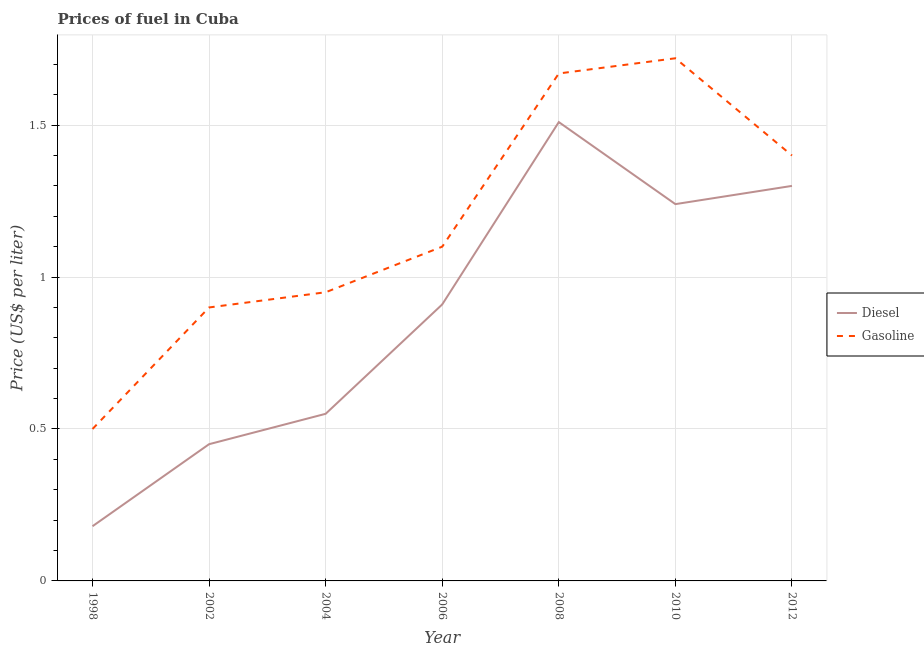Is the number of lines equal to the number of legend labels?
Give a very brief answer. Yes. What is the diesel price in 2004?
Provide a short and direct response. 0.55. Across all years, what is the maximum diesel price?
Make the answer very short. 1.51. Across all years, what is the minimum diesel price?
Offer a terse response. 0.18. In which year was the gasoline price maximum?
Make the answer very short. 2010. What is the total diesel price in the graph?
Provide a short and direct response. 6.14. What is the difference between the gasoline price in 2006 and that in 2010?
Make the answer very short. -0.62. What is the difference between the diesel price in 2012 and the gasoline price in 1998?
Offer a very short reply. 0.8. What is the average diesel price per year?
Your response must be concise. 0.88. In the year 2006, what is the difference between the diesel price and gasoline price?
Provide a short and direct response. -0.19. In how many years, is the gasoline price greater than 0.2 US$ per litre?
Make the answer very short. 7. What is the ratio of the diesel price in 2004 to that in 2008?
Provide a succinct answer. 0.36. What is the difference between the highest and the second highest gasoline price?
Your answer should be compact. 0.05. What is the difference between the highest and the lowest gasoline price?
Make the answer very short. 1.22. Does the gasoline price monotonically increase over the years?
Your answer should be very brief. No. How many lines are there?
Provide a succinct answer. 2. How many years are there in the graph?
Keep it short and to the point. 7. What is the difference between two consecutive major ticks on the Y-axis?
Make the answer very short. 0.5. Are the values on the major ticks of Y-axis written in scientific E-notation?
Give a very brief answer. No. What is the title of the graph?
Your answer should be compact. Prices of fuel in Cuba. Does "Exports" appear as one of the legend labels in the graph?
Your answer should be very brief. No. What is the label or title of the Y-axis?
Keep it short and to the point. Price (US$ per liter). What is the Price (US$ per liter) of Diesel in 1998?
Keep it short and to the point. 0.18. What is the Price (US$ per liter) in Diesel in 2002?
Your response must be concise. 0.45. What is the Price (US$ per liter) in Diesel in 2004?
Your answer should be very brief. 0.55. What is the Price (US$ per liter) of Diesel in 2006?
Give a very brief answer. 0.91. What is the Price (US$ per liter) in Diesel in 2008?
Give a very brief answer. 1.51. What is the Price (US$ per liter) in Gasoline in 2008?
Provide a short and direct response. 1.67. What is the Price (US$ per liter) of Diesel in 2010?
Offer a very short reply. 1.24. What is the Price (US$ per liter) in Gasoline in 2010?
Make the answer very short. 1.72. Across all years, what is the maximum Price (US$ per liter) in Diesel?
Ensure brevity in your answer.  1.51. Across all years, what is the maximum Price (US$ per liter) of Gasoline?
Offer a terse response. 1.72. Across all years, what is the minimum Price (US$ per liter) of Diesel?
Provide a short and direct response. 0.18. Across all years, what is the minimum Price (US$ per liter) in Gasoline?
Your answer should be compact. 0.5. What is the total Price (US$ per liter) in Diesel in the graph?
Give a very brief answer. 6.14. What is the total Price (US$ per liter) of Gasoline in the graph?
Keep it short and to the point. 8.24. What is the difference between the Price (US$ per liter) in Diesel in 1998 and that in 2002?
Your response must be concise. -0.27. What is the difference between the Price (US$ per liter) of Diesel in 1998 and that in 2004?
Offer a terse response. -0.37. What is the difference between the Price (US$ per liter) of Gasoline in 1998 and that in 2004?
Keep it short and to the point. -0.45. What is the difference between the Price (US$ per liter) of Diesel in 1998 and that in 2006?
Your answer should be very brief. -0.73. What is the difference between the Price (US$ per liter) of Gasoline in 1998 and that in 2006?
Provide a succinct answer. -0.6. What is the difference between the Price (US$ per liter) in Diesel in 1998 and that in 2008?
Your response must be concise. -1.33. What is the difference between the Price (US$ per liter) in Gasoline in 1998 and that in 2008?
Give a very brief answer. -1.17. What is the difference between the Price (US$ per liter) in Diesel in 1998 and that in 2010?
Provide a succinct answer. -1.06. What is the difference between the Price (US$ per liter) of Gasoline in 1998 and that in 2010?
Make the answer very short. -1.22. What is the difference between the Price (US$ per liter) of Diesel in 1998 and that in 2012?
Your answer should be compact. -1.12. What is the difference between the Price (US$ per liter) of Gasoline in 1998 and that in 2012?
Make the answer very short. -0.9. What is the difference between the Price (US$ per liter) in Gasoline in 2002 and that in 2004?
Give a very brief answer. -0.05. What is the difference between the Price (US$ per liter) of Diesel in 2002 and that in 2006?
Your response must be concise. -0.46. What is the difference between the Price (US$ per liter) in Gasoline in 2002 and that in 2006?
Provide a short and direct response. -0.2. What is the difference between the Price (US$ per liter) of Diesel in 2002 and that in 2008?
Provide a short and direct response. -1.06. What is the difference between the Price (US$ per liter) in Gasoline in 2002 and that in 2008?
Offer a very short reply. -0.77. What is the difference between the Price (US$ per liter) in Diesel in 2002 and that in 2010?
Ensure brevity in your answer.  -0.79. What is the difference between the Price (US$ per liter) of Gasoline in 2002 and that in 2010?
Your answer should be compact. -0.82. What is the difference between the Price (US$ per liter) in Diesel in 2002 and that in 2012?
Keep it short and to the point. -0.85. What is the difference between the Price (US$ per liter) of Diesel in 2004 and that in 2006?
Offer a very short reply. -0.36. What is the difference between the Price (US$ per liter) of Gasoline in 2004 and that in 2006?
Give a very brief answer. -0.15. What is the difference between the Price (US$ per liter) in Diesel in 2004 and that in 2008?
Offer a terse response. -0.96. What is the difference between the Price (US$ per liter) of Gasoline in 2004 and that in 2008?
Offer a terse response. -0.72. What is the difference between the Price (US$ per liter) in Diesel in 2004 and that in 2010?
Provide a short and direct response. -0.69. What is the difference between the Price (US$ per liter) of Gasoline in 2004 and that in 2010?
Your response must be concise. -0.77. What is the difference between the Price (US$ per liter) in Diesel in 2004 and that in 2012?
Offer a very short reply. -0.75. What is the difference between the Price (US$ per liter) of Gasoline in 2004 and that in 2012?
Offer a terse response. -0.45. What is the difference between the Price (US$ per liter) of Gasoline in 2006 and that in 2008?
Your answer should be compact. -0.57. What is the difference between the Price (US$ per liter) of Diesel in 2006 and that in 2010?
Your response must be concise. -0.33. What is the difference between the Price (US$ per liter) of Gasoline in 2006 and that in 2010?
Your answer should be very brief. -0.62. What is the difference between the Price (US$ per liter) in Diesel in 2006 and that in 2012?
Provide a short and direct response. -0.39. What is the difference between the Price (US$ per liter) of Gasoline in 2006 and that in 2012?
Your answer should be very brief. -0.3. What is the difference between the Price (US$ per liter) of Diesel in 2008 and that in 2010?
Make the answer very short. 0.27. What is the difference between the Price (US$ per liter) in Diesel in 2008 and that in 2012?
Your response must be concise. 0.21. What is the difference between the Price (US$ per liter) in Gasoline in 2008 and that in 2012?
Offer a terse response. 0.27. What is the difference between the Price (US$ per liter) of Diesel in 2010 and that in 2012?
Keep it short and to the point. -0.06. What is the difference between the Price (US$ per liter) of Gasoline in 2010 and that in 2012?
Keep it short and to the point. 0.32. What is the difference between the Price (US$ per liter) in Diesel in 1998 and the Price (US$ per liter) in Gasoline in 2002?
Offer a terse response. -0.72. What is the difference between the Price (US$ per liter) of Diesel in 1998 and the Price (US$ per liter) of Gasoline in 2004?
Provide a succinct answer. -0.77. What is the difference between the Price (US$ per liter) in Diesel in 1998 and the Price (US$ per liter) in Gasoline in 2006?
Make the answer very short. -0.92. What is the difference between the Price (US$ per liter) in Diesel in 1998 and the Price (US$ per liter) in Gasoline in 2008?
Your answer should be very brief. -1.49. What is the difference between the Price (US$ per liter) in Diesel in 1998 and the Price (US$ per liter) in Gasoline in 2010?
Ensure brevity in your answer.  -1.54. What is the difference between the Price (US$ per liter) of Diesel in 1998 and the Price (US$ per liter) of Gasoline in 2012?
Provide a short and direct response. -1.22. What is the difference between the Price (US$ per liter) in Diesel in 2002 and the Price (US$ per liter) in Gasoline in 2006?
Offer a very short reply. -0.65. What is the difference between the Price (US$ per liter) in Diesel in 2002 and the Price (US$ per liter) in Gasoline in 2008?
Provide a short and direct response. -1.22. What is the difference between the Price (US$ per liter) of Diesel in 2002 and the Price (US$ per liter) of Gasoline in 2010?
Give a very brief answer. -1.27. What is the difference between the Price (US$ per liter) of Diesel in 2002 and the Price (US$ per liter) of Gasoline in 2012?
Offer a very short reply. -0.95. What is the difference between the Price (US$ per liter) in Diesel in 2004 and the Price (US$ per liter) in Gasoline in 2006?
Provide a short and direct response. -0.55. What is the difference between the Price (US$ per liter) of Diesel in 2004 and the Price (US$ per liter) of Gasoline in 2008?
Make the answer very short. -1.12. What is the difference between the Price (US$ per liter) in Diesel in 2004 and the Price (US$ per liter) in Gasoline in 2010?
Your response must be concise. -1.17. What is the difference between the Price (US$ per liter) of Diesel in 2004 and the Price (US$ per liter) of Gasoline in 2012?
Provide a short and direct response. -0.85. What is the difference between the Price (US$ per liter) of Diesel in 2006 and the Price (US$ per liter) of Gasoline in 2008?
Your response must be concise. -0.76. What is the difference between the Price (US$ per liter) of Diesel in 2006 and the Price (US$ per liter) of Gasoline in 2010?
Your response must be concise. -0.81. What is the difference between the Price (US$ per liter) in Diesel in 2006 and the Price (US$ per liter) in Gasoline in 2012?
Provide a short and direct response. -0.49. What is the difference between the Price (US$ per liter) in Diesel in 2008 and the Price (US$ per liter) in Gasoline in 2010?
Offer a very short reply. -0.21. What is the difference between the Price (US$ per liter) of Diesel in 2008 and the Price (US$ per liter) of Gasoline in 2012?
Offer a very short reply. 0.11. What is the difference between the Price (US$ per liter) of Diesel in 2010 and the Price (US$ per liter) of Gasoline in 2012?
Give a very brief answer. -0.16. What is the average Price (US$ per liter) in Diesel per year?
Your answer should be very brief. 0.88. What is the average Price (US$ per liter) of Gasoline per year?
Your answer should be very brief. 1.18. In the year 1998, what is the difference between the Price (US$ per liter) in Diesel and Price (US$ per liter) in Gasoline?
Provide a short and direct response. -0.32. In the year 2002, what is the difference between the Price (US$ per liter) of Diesel and Price (US$ per liter) of Gasoline?
Keep it short and to the point. -0.45. In the year 2006, what is the difference between the Price (US$ per liter) of Diesel and Price (US$ per liter) of Gasoline?
Provide a succinct answer. -0.19. In the year 2008, what is the difference between the Price (US$ per liter) of Diesel and Price (US$ per liter) of Gasoline?
Keep it short and to the point. -0.16. In the year 2010, what is the difference between the Price (US$ per liter) of Diesel and Price (US$ per liter) of Gasoline?
Your answer should be very brief. -0.48. What is the ratio of the Price (US$ per liter) of Gasoline in 1998 to that in 2002?
Make the answer very short. 0.56. What is the ratio of the Price (US$ per liter) in Diesel in 1998 to that in 2004?
Keep it short and to the point. 0.33. What is the ratio of the Price (US$ per liter) in Gasoline in 1998 to that in 2004?
Provide a short and direct response. 0.53. What is the ratio of the Price (US$ per liter) of Diesel in 1998 to that in 2006?
Offer a terse response. 0.2. What is the ratio of the Price (US$ per liter) in Gasoline in 1998 to that in 2006?
Your answer should be compact. 0.45. What is the ratio of the Price (US$ per liter) of Diesel in 1998 to that in 2008?
Provide a succinct answer. 0.12. What is the ratio of the Price (US$ per liter) of Gasoline in 1998 to that in 2008?
Your answer should be compact. 0.3. What is the ratio of the Price (US$ per liter) in Diesel in 1998 to that in 2010?
Your answer should be very brief. 0.15. What is the ratio of the Price (US$ per liter) of Gasoline in 1998 to that in 2010?
Your answer should be very brief. 0.29. What is the ratio of the Price (US$ per liter) of Diesel in 1998 to that in 2012?
Ensure brevity in your answer.  0.14. What is the ratio of the Price (US$ per liter) of Gasoline in 1998 to that in 2012?
Your answer should be compact. 0.36. What is the ratio of the Price (US$ per liter) in Diesel in 2002 to that in 2004?
Give a very brief answer. 0.82. What is the ratio of the Price (US$ per liter) of Gasoline in 2002 to that in 2004?
Your response must be concise. 0.95. What is the ratio of the Price (US$ per liter) of Diesel in 2002 to that in 2006?
Your answer should be very brief. 0.49. What is the ratio of the Price (US$ per liter) in Gasoline in 2002 to that in 2006?
Make the answer very short. 0.82. What is the ratio of the Price (US$ per liter) of Diesel in 2002 to that in 2008?
Your answer should be compact. 0.3. What is the ratio of the Price (US$ per liter) of Gasoline in 2002 to that in 2008?
Ensure brevity in your answer.  0.54. What is the ratio of the Price (US$ per liter) of Diesel in 2002 to that in 2010?
Offer a terse response. 0.36. What is the ratio of the Price (US$ per liter) of Gasoline in 2002 to that in 2010?
Your response must be concise. 0.52. What is the ratio of the Price (US$ per liter) in Diesel in 2002 to that in 2012?
Provide a short and direct response. 0.35. What is the ratio of the Price (US$ per liter) of Gasoline in 2002 to that in 2012?
Ensure brevity in your answer.  0.64. What is the ratio of the Price (US$ per liter) of Diesel in 2004 to that in 2006?
Provide a short and direct response. 0.6. What is the ratio of the Price (US$ per liter) in Gasoline in 2004 to that in 2006?
Your response must be concise. 0.86. What is the ratio of the Price (US$ per liter) in Diesel in 2004 to that in 2008?
Offer a very short reply. 0.36. What is the ratio of the Price (US$ per liter) in Gasoline in 2004 to that in 2008?
Provide a succinct answer. 0.57. What is the ratio of the Price (US$ per liter) of Diesel in 2004 to that in 2010?
Your response must be concise. 0.44. What is the ratio of the Price (US$ per liter) of Gasoline in 2004 to that in 2010?
Ensure brevity in your answer.  0.55. What is the ratio of the Price (US$ per liter) of Diesel in 2004 to that in 2012?
Your answer should be very brief. 0.42. What is the ratio of the Price (US$ per liter) in Gasoline in 2004 to that in 2012?
Provide a succinct answer. 0.68. What is the ratio of the Price (US$ per liter) of Diesel in 2006 to that in 2008?
Make the answer very short. 0.6. What is the ratio of the Price (US$ per liter) in Gasoline in 2006 to that in 2008?
Your answer should be very brief. 0.66. What is the ratio of the Price (US$ per liter) in Diesel in 2006 to that in 2010?
Make the answer very short. 0.73. What is the ratio of the Price (US$ per liter) in Gasoline in 2006 to that in 2010?
Keep it short and to the point. 0.64. What is the ratio of the Price (US$ per liter) of Diesel in 2006 to that in 2012?
Your answer should be very brief. 0.7. What is the ratio of the Price (US$ per liter) of Gasoline in 2006 to that in 2012?
Ensure brevity in your answer.  0.79. What is the ratio of the Price (US$ per liter) of Diesel in 2008 to that in 2010?
Make the answer very short. 1.22. What is the ratio of the Price (US$ per liter) of Gasoline in 2008 to that in 2010?
Offer a very short reply. 0.97. What is the ratio of the Price (US$ per liter) of Diesel in 2008 to that in 2012?
Offer a very short reply. 1.16. What is the ratio of the Price (US$ per liter) in Gasoline in 2008 to that in 2012?
Your answer should be compact. 1.19. What is the ratio of the Price (US$ per liter) in Diesel in 2010 to that in 2012?
Make the answer very short. 0.95. What is the ratio of the Price (US$ per liter) in Gasoline in 2010 to that in 2012?
Your response must be concise. 1.23. What is the difference between the highest and the second highest Price (US$ per liter) in Diesel?
Your response must be concise. 0.21. What is the difference between the highest and the lowest Price (US$ per liter) of Diesel?
Offer a very short reply. 1.33. What is the difference between the highest and the lowest Price (US$ per liter) of Gasoline?
Keep it short and to the point. 1.22. 